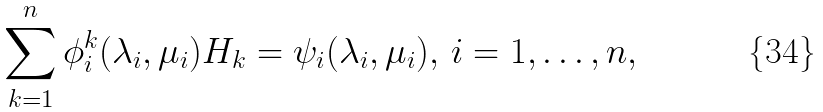Convert formula to latex. <formula><loc_0><loc_0><loc_500><loc_500>\sum _ { k = 1 } ^ { n } \phi _ { i } ^ { k } ( \lambda _ { i } , \mu _ { i } ) H _ { k } = \psi _ { i } ( \lambda _ { i } , \mu _ { i } ) , \, i = 1 , \dots , n ,</formula> 